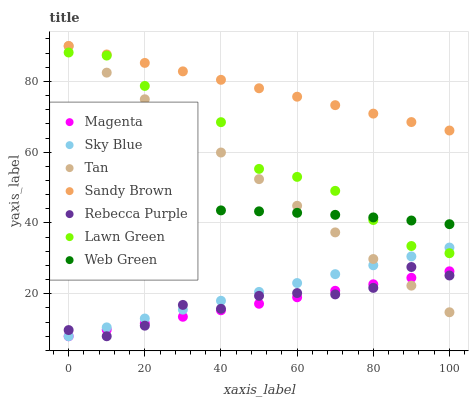Does Magenta have the minimum area under the curve?
Answer yes or no. Yes. Does Sandy Brown have the maximum area under the curve?
Answer yes or no. Yes. Does Web Green have the minimum area under the curve?
Answer yes or no. No. Does Web Green have the maximum area under the curve?
Answer yes or no. No. Is Sky Blue the smoothest?
Answer yes or no. Yes. Is Lawn Green the roughest?
Answer yes or no. Yes. Is Web Green the smoothest?
Answer yes or no. No. Is Web Green the roughest?
Answer yes or no. No. Does Rebecca Purple have the lowest value?
Answer yes or no. Yes. Does Web Green have the lowest value?
Answer yes or no. No. Does Tan have the highest value?
Answer yes or no. Yes. Does Web Green have the highest value?
Answer yes or no. No. Is Lawn Green less than Sandy Brown?
Answer yes or no. Yes. Is Sandy Brown greater than Lawn Green?
Answer yes or no. Yes. Does Magenta intersect Tan?
Answer yes or no. Yes. Is Magenta less than Tan?
Answer yes or no. No. Is Magenta greater than Tan?
Answer yes or no. No. Does Lawn Green intersect Sandy Brown?
Answer yes or no. No. 